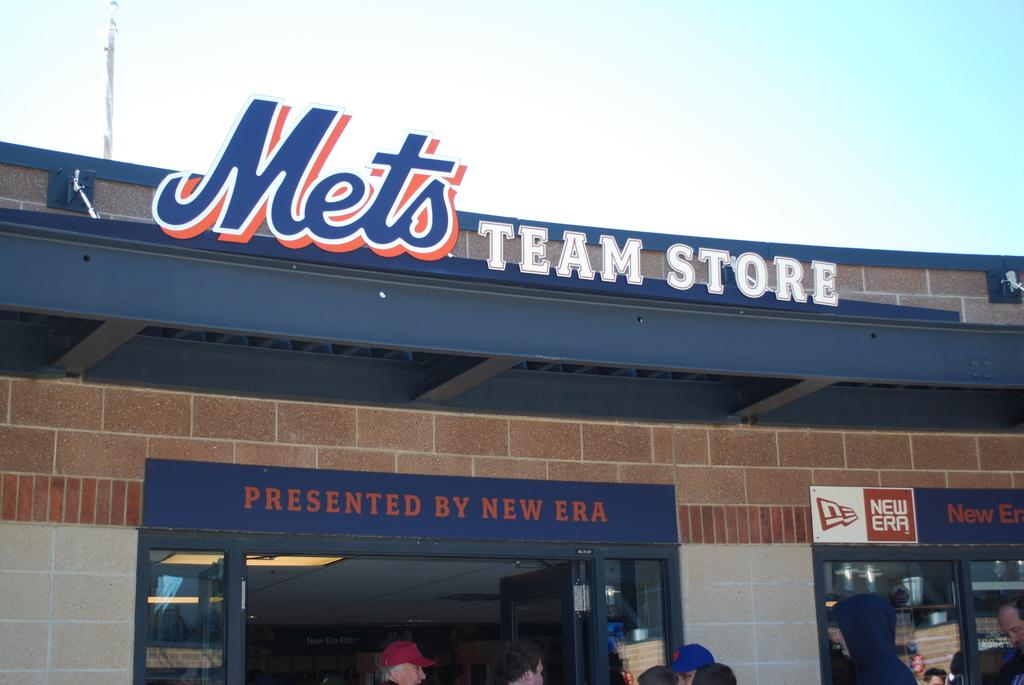Who or what can be seen in the image? There are people in the image. What type of establishment is present in the image? There is a store in the image. What objects are made of wood in the image? There are boards in the image. What type of structure is visible in the image? There is a wall in the image. What vertical object can be seen in the image? There is a pole in the image. What is visible in the distance in the image? The sky is visible in the background of the image. What type of tooth is visible on the wall in the image? There is no tooth visible on the wall in the image. How many doors can be seen in the image? There is no door present in the image. 